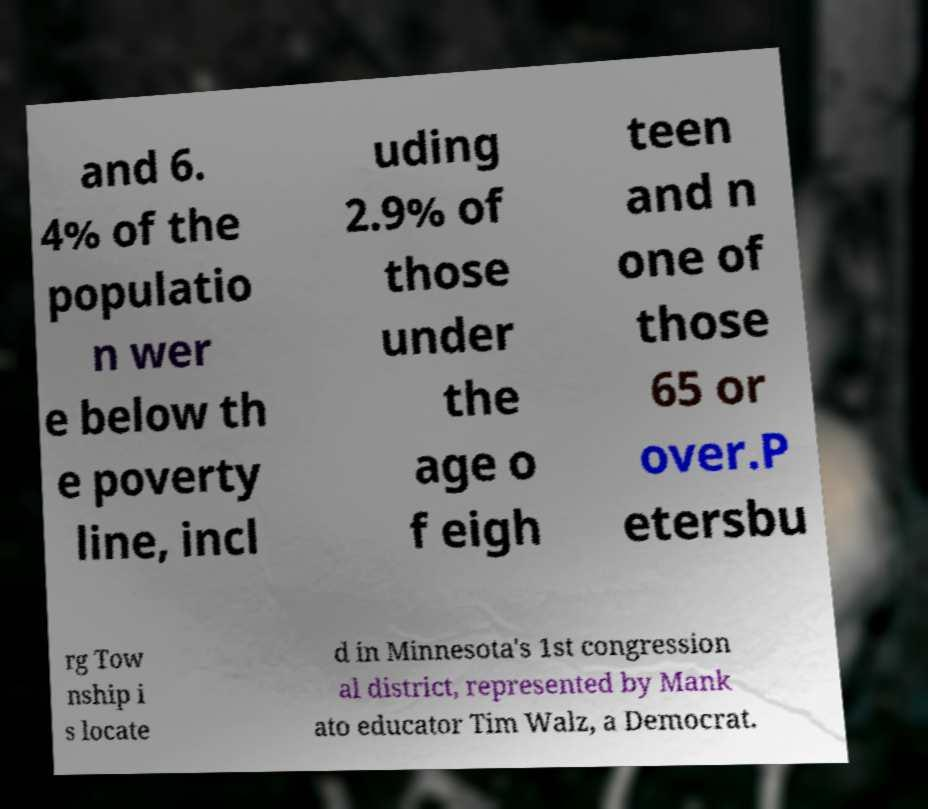Could you extract and type out the text from this image? and 6. 4% of the populatio n wer e below th e poverty line, incl uding 2.9% of those under the age o f eigh teen and n one of those 65 or over.P etersbu rg Tow nship i s locate d in Minnesota's 1st congression al district, represented by Mank ato educator Tim Walz, a Democrat. 